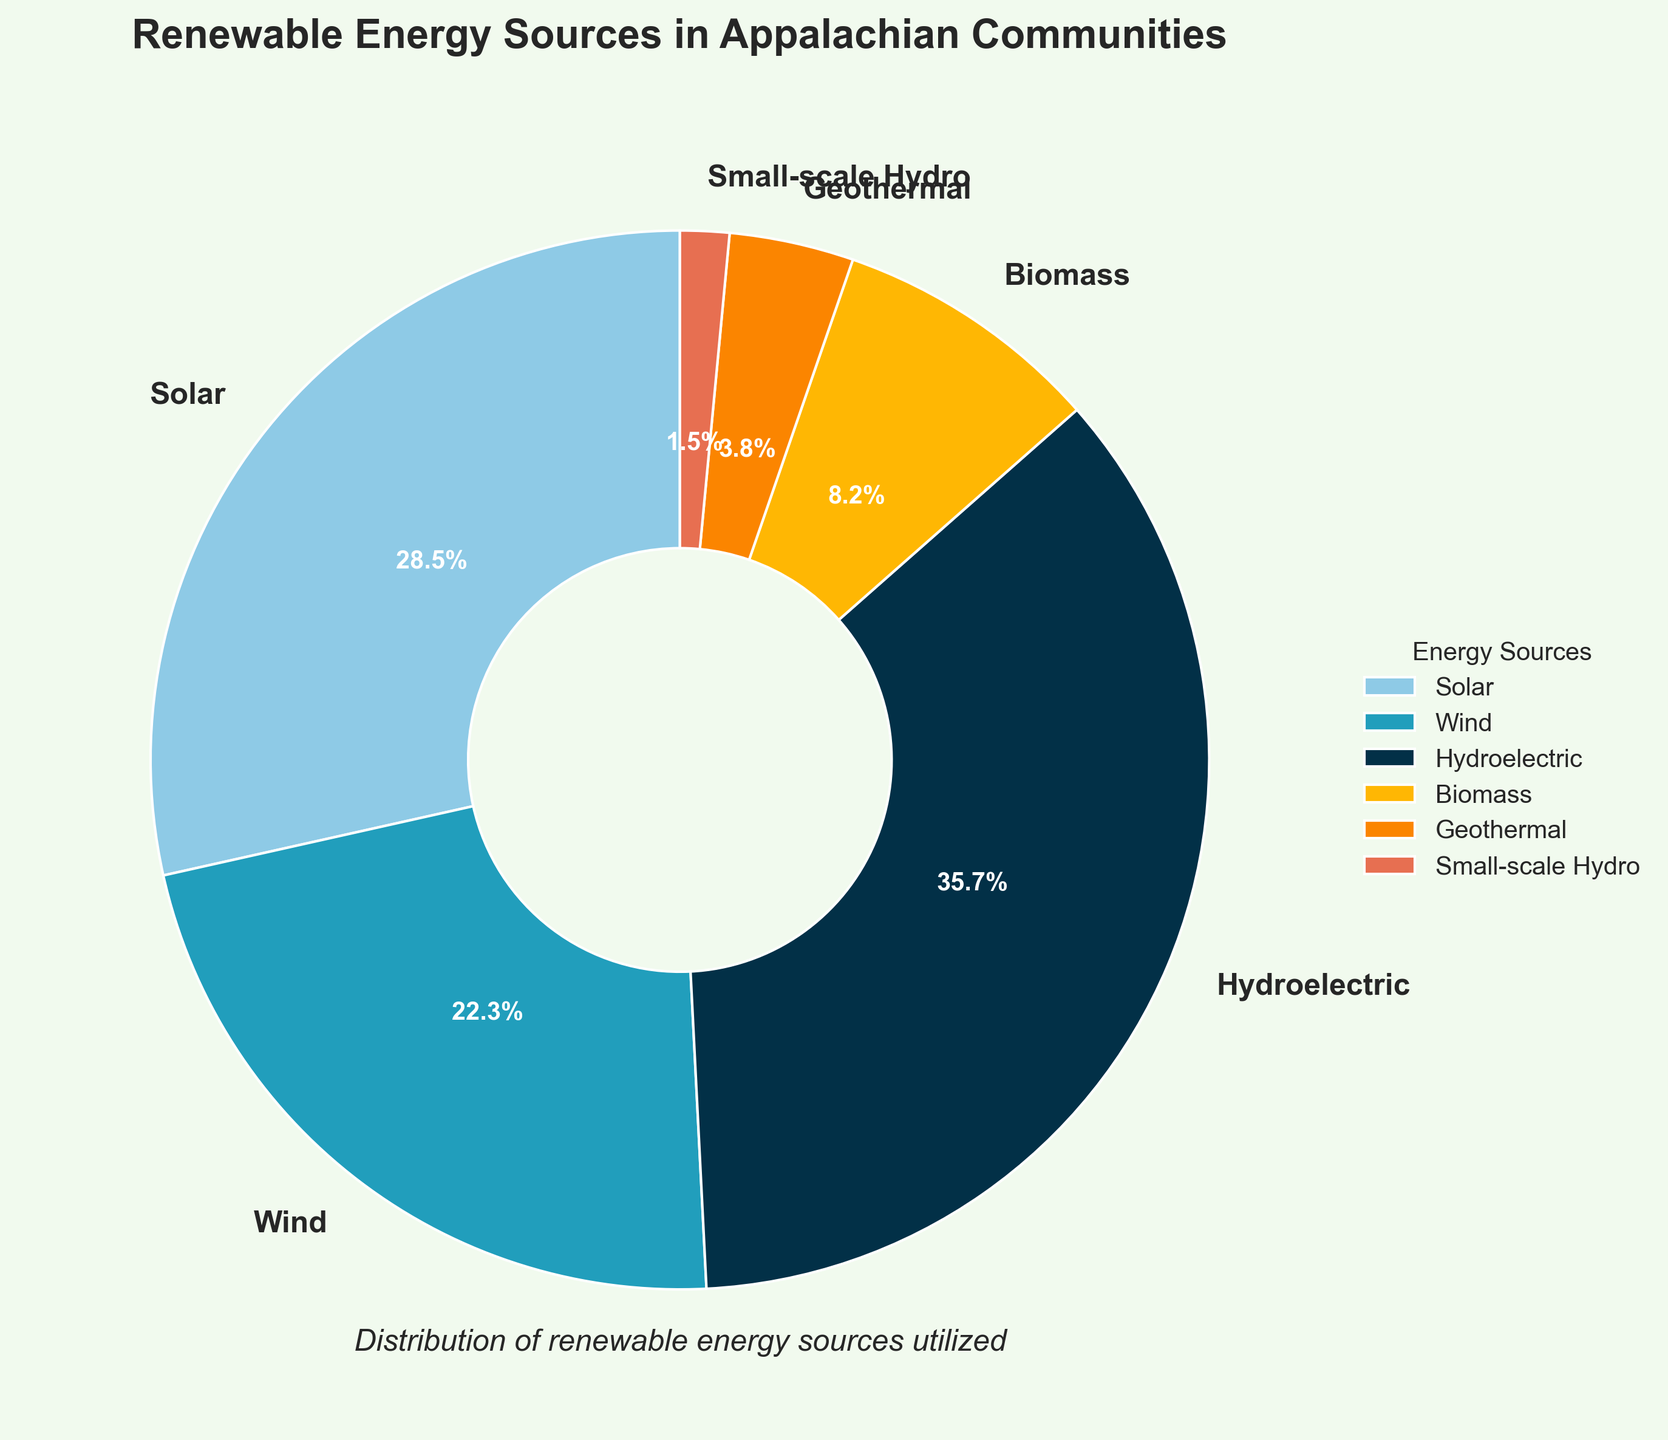Which energy source is utilized the most in Appalachian communities? By inspecting the percentages in the pie chart, it's clear that Hydroelectric has the highest percentage.
Answer: Hydroelectric Which energy source comes after Hydroelectric in terms of utilization? After Hydroelectric, which constitutes 35.7%, Solar energy is the next in line with 28.5%.
Answer: Solar What is the combined percentage of Wind and Biomass energy sources? To find the combined percentage, simply add the two values: Wind (22.3%) + Biomass (8.2%) = 30.5%.
Answer: 30.5% Is the percentage of Geothermal energy sources greater than that of Biomass? Comparing the two percentages, Geothermal (3.8%) is less than Biomass (8.2%).
Answer: No What is the difference in percentage between Solar and Wind energy sources? Subtract the percentage of Wind from Solar: Solar (28.5%) - Wind (22.3%) = 6.2%.
Answer: 6.2% How many energy sources have a utilization percentage of over 20%? By reviewing the chart, Hydroelectric (35.7%), Solar (28.5%), and Wind (22.3%) each have a utilization percentage above 20%.
Answer: 3 Which energy source has the smallest utilization percentage, and what is it? The energy source with the smallest utilization percentage is Small-scale Hydro at 1.5%.
Answer: Small-scale Hydro, 1.5% What is the average percentage of Solar, Wind, and Hydroelectric energy sources? Add the percentages and divide by the number of sources: (28.5% + 22.3% + 35.7%) / 3 = 86.5% / 3 ≈ 28.83%.
Answer: 28.83% Are there more energy sources with utilization percentages below or above 10%? Count the sources above 10%: Solar, Wind, and Hydroelectric (3 sources). Count the sources below 10%: Biomass, Geothermal, and Small-scale Hydro (3 sources). There are equal numbers.
Answer: Equal What color represents the Hydroelectric energy source in the pie chart? Inspecting the chart shows that Hydroelectric is represented by a distinct color, typically indicated in the legend for clarity.
Answer: Specific color indicated in chart legend 